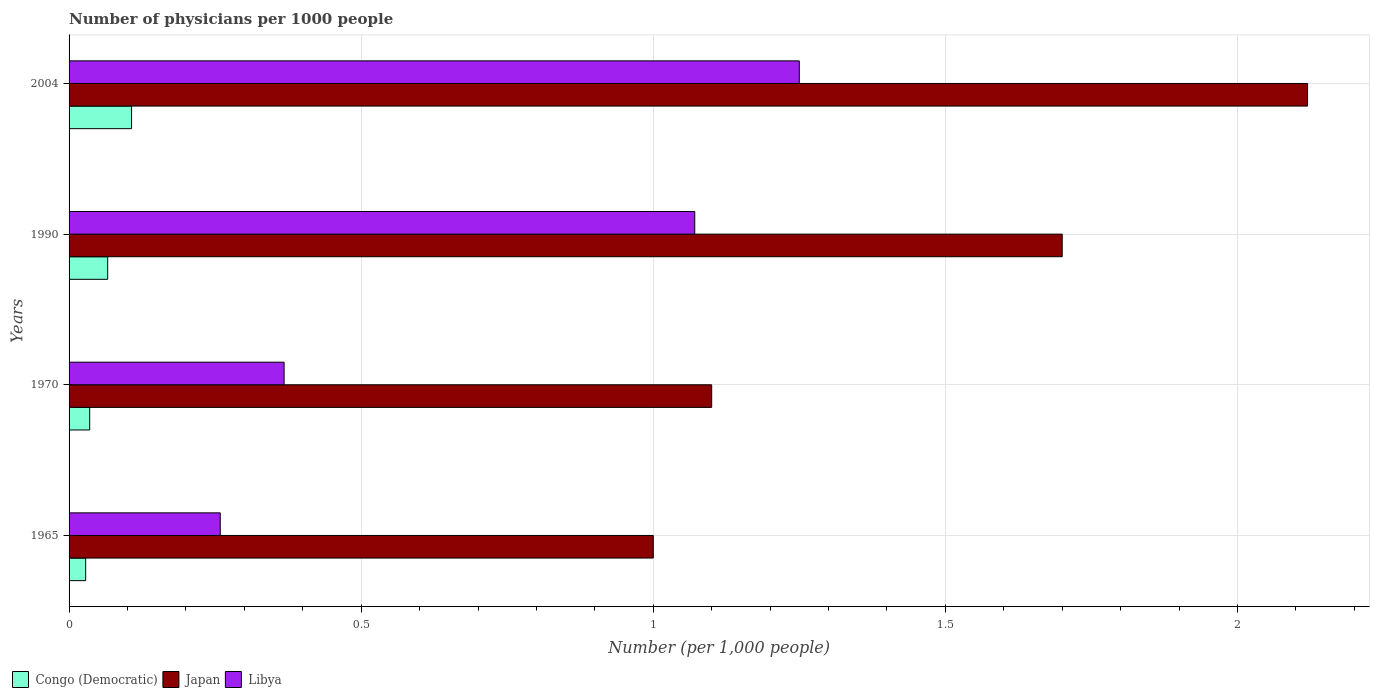Are the number of bars on each tick of the Y-axis equal?
Provide a short and direct response. Yes. How many bars are there on the 2nd tick from the bottom?
Keep it short and to the point. 3. In how many cases, is the number of bars for a given year not equal to the number of legend labels?
Your response must be concise. 0. What is the number of physicians in Japan in 1970?
Offer a very short reply. 1.1. Across all years, what is the maximum number of physicians in Japan?
Provide a short and direct response. 2.12. In which year was the number of physicians in Congo (Democratic) maximum?
Offer a terse response. 2004. In which year was the number of physicians in Congo (Democratic) minimum?
Ensure brevity in your answer.  1965. What is the total number of physicians in Congo (Democratic) in the graph?
Your answer should be compact. 0.24. What is the difference between the number of physicians in Congo (Democratic) in 1970 and that in 2004?
Keep it short and to the point. -0.07. What is the difference between the number of physicians in Japan in 1970 and the number of physicians in Libya in 1965?
Your answer should be compact. 0.84. What is the average number of physicians in Libya per year?
Ensure brevity in your answer.  0.74. In the year 2004, what is the difference between the number of physicians in Congo (Democratic) and number of physicians in Libya?
Your answer should be compact. -1.14. In how many years, is the number of physicians in Libya greater than 1.8 ?
Your response must be concise. 0. What is the ratio of the number of physicians in Japan in 1970 to that in 2004?
Your answer should be very brief. 0.52. Is the number of physicians in Congo (Democratic) in 1965 less than that in 2004?
Your response must be concise. Yes. What is the difference between the highest and the second highest number of physicians in Japan?
Offer a terse response. 0.42. What is the difference between the highest and the lowest number of physicians in Libya?
Your answer should be very brief. 0.99. What does the 3rd bar from the top in 2004 represents?
Provide a succinct answer. Congo (Democratic). What does the 3rd bar from the bottom in 1965 represents?
Provide a succinct answer. Libya. Is it the case that in every year, the sum of the number of physicians in Japan and number of physicians in Congo (Democratic) is greater than the number of physicians in Libya?
Provide a succinct answer. Yes. How many bars are there?
Provide a short and direct response. 12. How many years are there in the graph?
Provide a succinct answer. 4. What is the difference between two consecutive major ticks on the X-axis?
Your response must be concise. 0.5. Are the values on the major ticks of X-axis written in scientific E-notation?
Provide a succinct answer. No. How are the legend labels stacked?
Keep it short and to the point. Horizontal. What is the title of the graph?
Offer a terse response. Number of physicians per 1000 people. What is the label or title of the X-axis?
Give a very brief answer. Number (per 1,0 people). What is the label or title of the Y-axis?
Your answer should be very brief. Years. What is the Number (per 1,000 people) in Congo (Democratic) in 1965?
Give a very brief answer. 0.03. What is the Number (per 1,000 people) in Libya in 1965?
Offer a terse response. 0.26. What is the Number (per 1,000 people) in Congo (Democratic) in 1970?
Offer a terse response. 0.04. What is the Number (per 1,000 people) in Japan in 1970?
Give a very brief answer. 1.1. What is the Number (per 1,000 people) of Libya in 1970?
Your answer should be very brief. 0.37. What is the Number (per 1,000 people) in Congo (Democratic) in 1990?
Your response must be concise. 0.07. What is the Number (per 1,000 people) of Japan in 1990?
Your answer should be compact. 1.7. What is the Number (per 1,000 people) in Libya in 1990?
Your response must be concise. 1.07. What is the Number (per 1,000 people) in Congo (Democratic) in 2004?
Offer a very short reply. 0.11. What is the Number (per 1,000 people) in Japan in 2004?
Make the answer very short. 2.12. Across all years, what is the maximum Number (per 1,000 people) in Congo (Democratic)?
Offer a very short reply. 0.11. Across all years, what is the maximum Number (per 1,000 people) in Japan?
Make the answer very short. 2.12. Across all years, what is the maximum Number (per 1,000 people) of Libya?
Provide a succinct answer. 1.25. Across all years, what is the minimum Number (per 1,000 people) of Congo (Democratic)?
Offer a very short reply. 0.03. Across all years, what is the minimum Number (per 1,000 people) of Libya?
Offer a very short reply. 0.26. What is the total Number (per 1,000 people) of Congo (Democratic) in the graph?
Your answer should be compact. 0.24. What is the total Number (per 1,000 people) of Japan in the graph?
Offer a very short reply. 5.92. What is the total Number (per 1,000 people) in Libya in the graph?
Make the answer very short. 2.95. What is the difference between the Number (per 1,000 people) of Congo (Democratic) in 1965 and that in 1970?
Your answer should be compact. -0.01. What is the difference between the Number (per 1,000 people) of Japan in 1965 and that in 1970?
Make the answer very short. -0.1. What is the difference between the Number (per 1,000 people) in Libya in 1965 and that in 1970?
Provide a short and direct response. -0.11. What is the difference between the Number (per 1,000 people) of Congo (Democratic) in 1965 and that in 1990?
Give a very brief answer. -0.04. What is the difference between the Number (per 1,000 people) of Libya in 1965 and that in 1990?
Make the answer very short. -0.81. What is the difference between the Number (per 1,000 people) of Congo (Democratic) in 1965 and that in 2004?
Keep it short and to the point. -0.08. What is the difference between the Number (per 1,000 people) of Japan in 1965 and that in 2004?
Give a very brief answer. -1.12. What is the difference between the Number (per 1,000 people) of Libya in 1965 and that in 2004?
Provide a succinct answer. -0.99. What is the difference between the Number (per 1,000 people) in Congo (Democratic) in 1970 and that in 1990?
Give a very brief answer. -0.03. What is the difference between the Number (per 1,000 people) of Libya in 1970 and that in 1990?
Offer a terse response. -0.7. What is the difference between the Number (per 1,000 people) of Congo (Democratic) in 1970 and that in 2004?
Offer a very short reply. -0.07. What is the difference between the Number (per 1,000 people) in Japan in 1970 and that in 2004?
Provide a succinct answer. -1.02. What is the difference between the Number (per 1,000 people) of Libya in 1970 and that in 2004?
Your answer should be compact. -0.88. What is the difference between the Number (per 1,000 people) in Congo (Democratic) in 1990 and that in 2004?
Keep it short and to the point. -0.04. What is the difference between the Number (per 1,000 people) of Japan in 1990 and that in 2004?
Make the answer very short. -0.42. What is the difference between the Number (per 1,000 people) of Libya in 1990 and that in 2004?
Your answer should be very brief. -0.18. What is the difference between the Number (per 1,000 people) of Congo (Democratic) in 1965 and the Number (per 1,000 people) of Japan in 1970?
Provide a short and direct response. -1.07. What is the difference between the Number (per 1,000 people) of Congo (Democratic) in 1965 and the Number (per 1,000 people) of Libya in 1970?
Ensure brevity in your answer.  -0.34. What is the difference between the Number (per 1,000 people) of Japan in 1965 and the Number (per 1,000 people) of Libya in 1970?
Make the answer very short. 0.63. What is the difference between the Number (per 1,000 people) of Congo (Democratic) in 1965 and the Number (per 1,000 people) of Japan in 1990?
Your answer should be compact. -1.67. What is the difference between the Number (per 1,000 people) in Congo (Democratic) in 1965 and the Number (per 1,000 people) in Libya in 1990?
Your answer should be compact. -1.04. What is the difference between the Number (per 1,000 people) of Japan in 1965 and the Number (per 1,000 people) of Libya in 1990?
Your response must be concise. -0.07. What is the difference between the Number (per 1,000 people) of Congo (Democratic) in 1965 and the Number (per 1,000 people) of Japan in 2004?
Give a very brief answer. -2.09. What is the difference between the Number (per 1,000 people) in Congo (Democratic) in 1965 and the Number (per 1,000 people) in Libya in 2004?
Provide a succinct answer. -1.22. What is the difference between the Number (per 1,000 people) in Congo (Democratic) in 1970 and the Number (per 1,000 people) in Japan in 1990?
Ensure brevity in your answer.  -1.66. What is the difference between the Number (per 1,000 people) of Congo (Democratic) in 1970 and the Number (per 1,000 people) of Libya in 1990?
Give a very brief answer. -1.04. What is the difference between the Number (per 1,000 people) of Japan in 1970 and the Number (per 1,000 people) of Libya in 1990?
Your answer should be compact. 0.03. What is the difference between the Number (per 1,000 people) in Congo (Democratic) in 1970 and the Number (per 1,000 people) in Japan in 2004?
Your answer should be compact. -2.08. What is the difference between the Number (per 1,000 people) in Congo (Democratic) in 1970 and the Number (per 1,000 people) in Libya in 2004?
Your answer should be very brief. -1.21. What is the difference between the Number (per 1,000 people) of Japan in 1970 and the Number (per 1,000 people) of Libya in 2004?
Your answer should be compact. -0.15. What is the difference between the Number (per 1,000 people) of Congo (Democratic) in 1990 and the Number (per 1,000 people) of Japan in 2004?
Provide a short and direct response. -2.05. What is the difference between the Number (per 1,000 people) of Congo (Democratic) in 1990 and the Number (per 1,000 people) of Libya in 2004?
Your answer should be compact. -1.18. What is the difference between the Number (per 1,000 people) in Japan in 1990 and the Number (per 1,000 people) in Libya in 2004?
Offer a very short reply. 0.45. What is the average Number (per 1,000 people) in Congo (Democratic) per year?
Offer a terse response. 0.06. What is the average Number (per 1,000 people) in Japan per year?
Provide a short and direct response. 1.48. What is the average Number (per 1,000 people) of Libya per year?
Offer a terse response. 0.74. In the year 1965, what is the difference between the Number (per 1,000 people) of Congo (Democratic) and Number (per 1,000 people) of Japan?
Offer a terse response. -0.97. In the year 1965, what is the difference between the Number (per 1,000 people) of Congo (Democratic) and Number (per 1,000 people) of Libya?
Offer a terse response. -0.23. In the year 1965, what is the difference between the Number (per 1,000 people) in Japan and Number (per 1,000 people) in Libya?
Your response must be concise. 0.74. In the year 1970, what is the difference between the Number (per 1,000 people) of Congo (Democratic) and Number (per 1,000 people) of Japan?
Offer a very short reply. -1.06. In the year 1970, what is the difference between the Number (per 1,000 people) of Congo (Democratic) and Number (per 1,000 people) of Libya?
Offer a very short reply. -0.33. In the year 1970, what is the difference between the Number (per 1,000 people) of Japan and Number (per 1,000 people) of Libya?
Provide a succinct answer. 0.73. In the year 1990, what is the difference between the Number (per 1,000 people) in Congo (Democratic) and Number (per 1,000 people) in Japan?
Offer a very short reply. -1.63. In the year 1990, what is the difference between the Number (per 1,000 people) of Congo (Democratic) and Number (per 1,000 people) of Libya?
Keep it short and to the point. -1. In the year 1990, what is the difference between the Number (per 1,000 people) of Japan and Number (per 1,000 people) of Libya?
Your answer should be very brief. 0.63. In the year 2004, what is the difference between the Number (per 1,000 people) in Congo (Democratic) and Number (per 1,000 people) in Japan?
Your answer should be very brief. -2.01. In the year 2004, what is the difference between the Number (per 1,000 people) in Congo (Democratic) and Number (per 1,000 people) in Libya?
Your answer should be compact. -1.14. In the year 2004, what is the difference between the Number (per 1,000 people) in Japan and Number (per 1,000 people) in Libya?
Your answer should be compact. 0.87. What is the ratio of the Number (per 1,000 people) of Congo (Democratic) in 1965 to that in 1970?
Offer a terse response. 0.81. What is the ratio of the Number (per 1,000 people) in Libya in 1965 to that in 1970?
Ensure brevity in your answer.  0.7. What is the ratio of the Number (per 1,000 people) of Congo (Democratic) in 1965 to that in 1990?
Give a very brief answer. 0.43. What is the ratio of the Number (per 1,000 people) in Japan in 1965 to that in 1990?
Ensure brevity in your answer.  0.59. What is the ratio of the Number (per 1,000 people) of Libya in 1965 to that in 1990?
Offer a terse response. 0.24. What is the ratio of the Number (per 1,000 people) in Congo (Democratic) in 1965 to that in 2004?
Your answer should be very brief. 0.27. What is the ratio of the Number (per 1,000 people) of Japan in 1965 to that in 2004?
Give a very brief answer. 0.47. What is the ratio of the Number (per 1,000 people) of Libya in 1965 to that in 2004?
Your answer should be very brief. 0.21. What is the ratio of the Number (per 1,000 people) in Congo (Democratic) in 1970 to that in 1990?
Ensure brevity in your answer.  0.53. What is the ratio of the Number (per 1,000 people) of Japan in 1970 to that in 1990?
Keep it short and to the point. 0.65. What is the ratio of the Number (per 1,000 people) of Libya in 1970 to that in 1990?
Offer a terse response. 0.34. What is the ratio of the Number (per 1,000 people) in Congo (Democratic) in 1970 to that in 2004?
Your answer should be very brief. 0.33. What is the ratio of the Number (per 1,000 people) in Japan in 1970 to that in 2004?
Offer a very short reply. 0.52. What is the ratio of the Number (per 1,000 people) of Libya in 1970 to that in 2004?
Your answer should be very brief. 0.29. What is the ratio of the Number (per 1,000 people) in Congo (Democratic) in 1990 to that in 2004?
Keep it short and to the point. 0.62. What is the ratio of the Number (per 1,000 people) of Japan in 1990 to that in 2004?
Make the answer very short. 0.8. What is the ratio of the Number (per 1,000 people) of Libya in 1990 to that in 2004?
Give a very brief answer. 0.86. What is the difference between the highest and the second highest Number (per 1,000 people) of Congo (Democratic)?
Offer a terse response. 0.04. What is the difference between the highest and the second highest Number (per 1,000 people) in Japan?
Give a very brief answer. 0.42. What is the difference between the highest and the second highest Number (per 1,000 people) of Libya?
Make the answer very short. 0.18. What is the difference between the highest and the lowest Number (per 1,000 people) of Congo (Democratic)?
Ensure brevity in your answer.  0.08. What is the difference between the highest and the lowest Number (per 1,000 people) in Japan?
Offer a terse response. 1.12. 